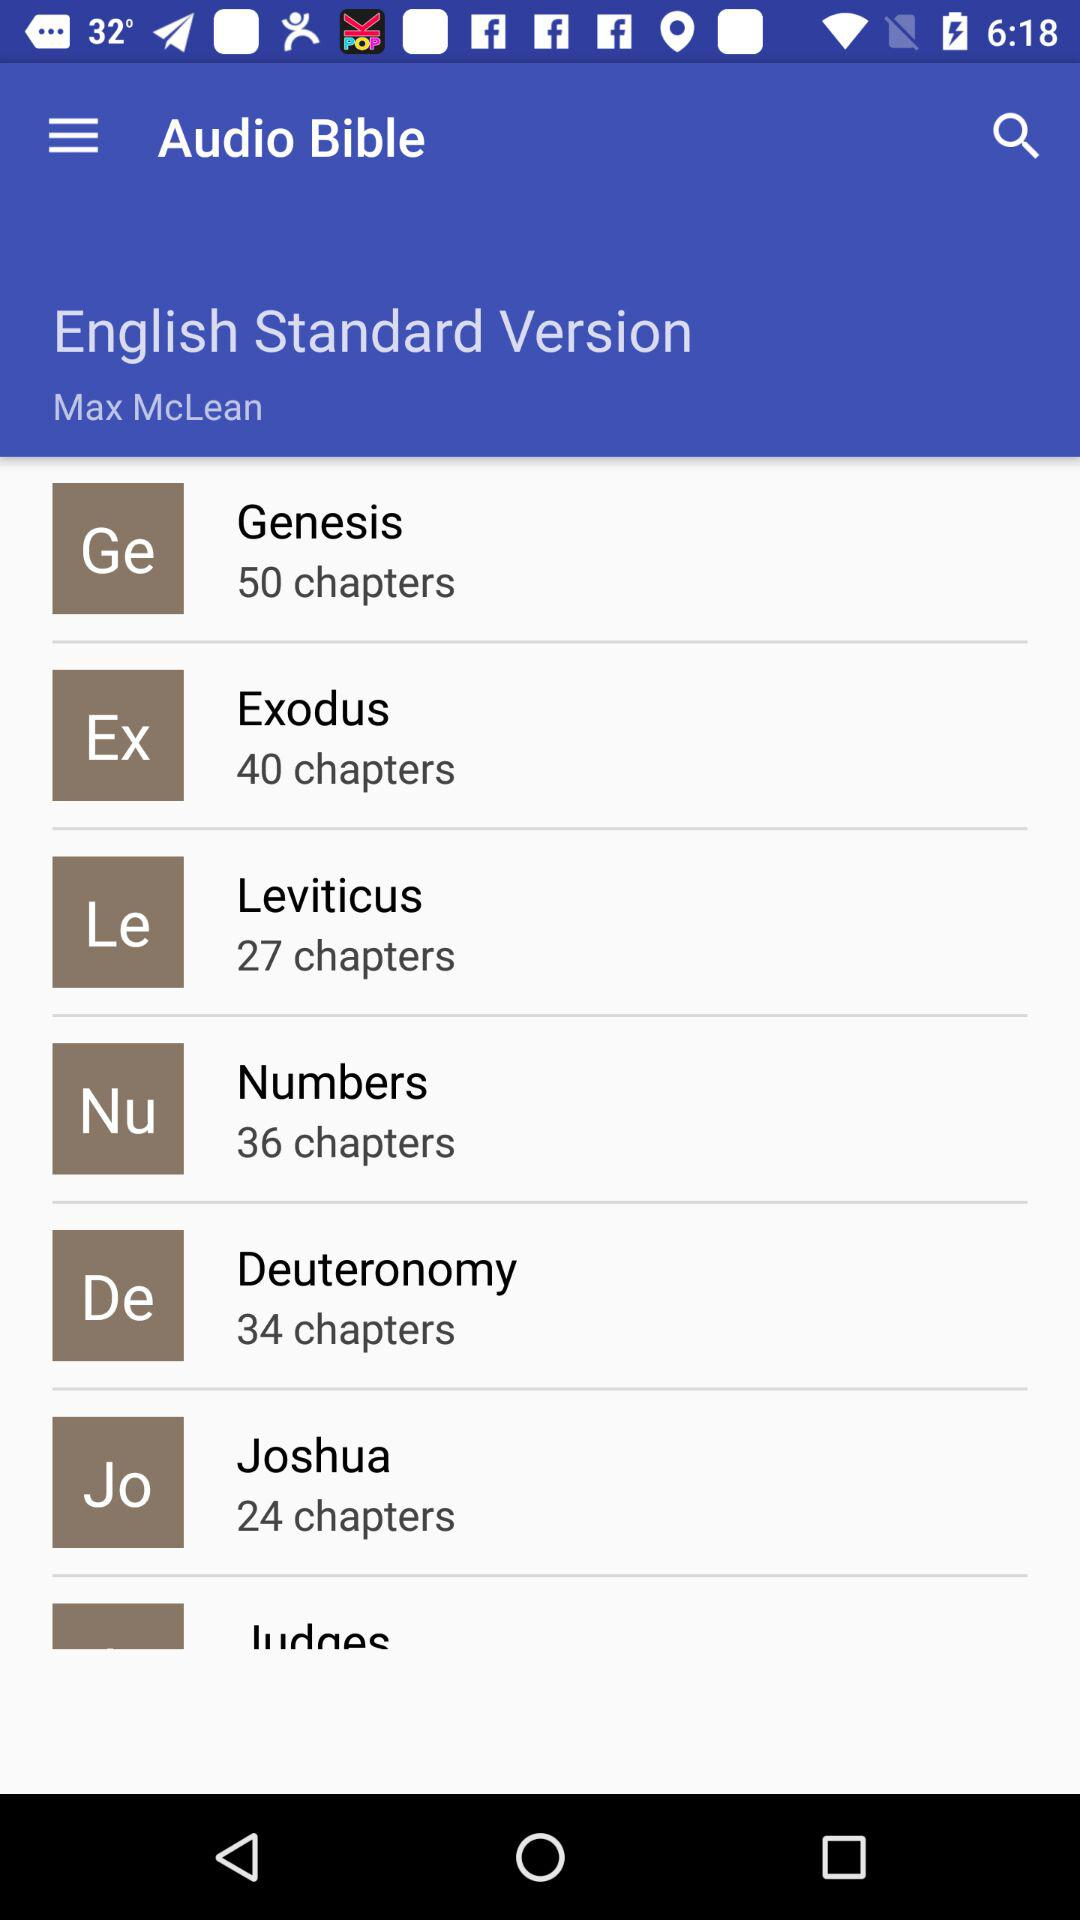In what version is the "Audio Bible" available? It is available in the "English Standard Version". 